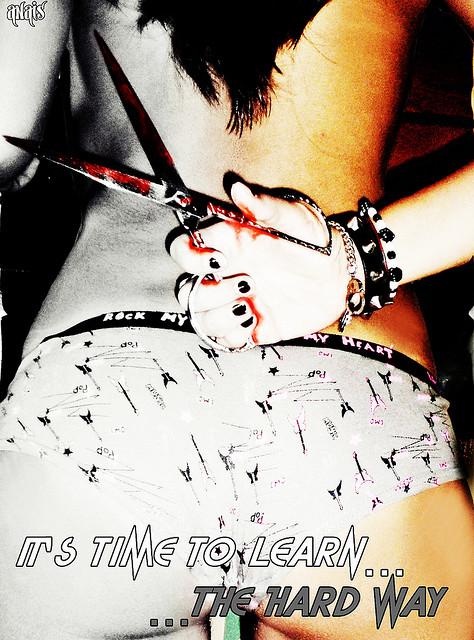What color are the scissors?
Keep it brief. Silver. What time is it?
Write a very short answer. Time to learn hard way. Does this girl have on pants?
Write a very short answer. No. 